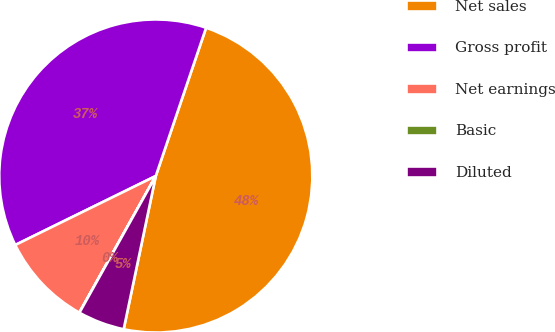Convert chart. <chart><loc_0><loc_0><loc_500><loc_500><pie_chart><fcel>Net sales<fcel>Gross profit<fcel>Net earnings<fcel>Basic<fcel>Diluted<nl><fcel>48.08%<fcel>37.47%<fcel>9.62%<fcel>0.01%<fcel>4.82%<nl></chart> 